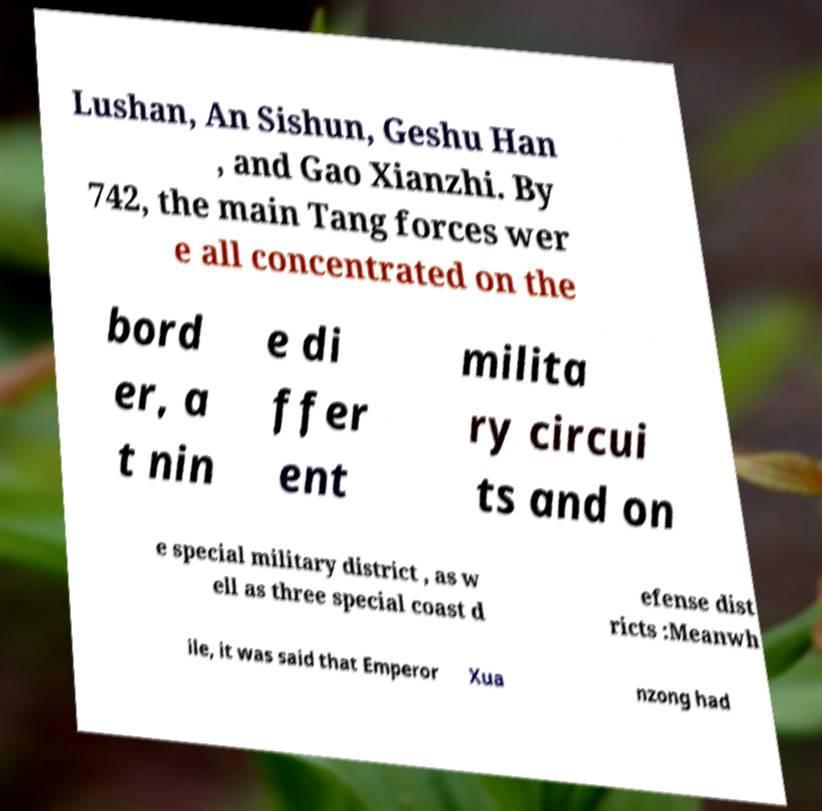Can you accurately transcribe the text from the provided image for me? Lushan, An Sishun, Geshu Han , and Gao Xianzhi. By 742, the main Tang forces wer e all concentrated on the bord er, a t nin e di ffer ent milita ry circui ts and on e special military district , as w ell as three special coast d efense dist ricts :Meanwh ile, it was said that Emperor Xua nzong had 